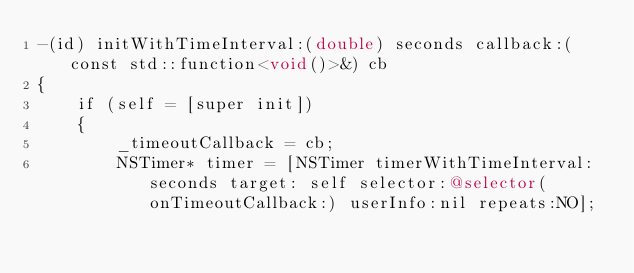<code> <loc_0><loc_0><loc_500><loc_500><_ObjectiveC_>-(id) initWithTimeInterval:(double) seconds callback:(const std::function<void()>&) cb
{
    if (self = [super init])
    {
        _timeoutCallback = cb;
        NSTimer* timer = [NSTimer timerWithTimeInterval:seconds target: self selector:@selector(onTimeoutCallback:) userInfo:nil repeats:NO];</code> 